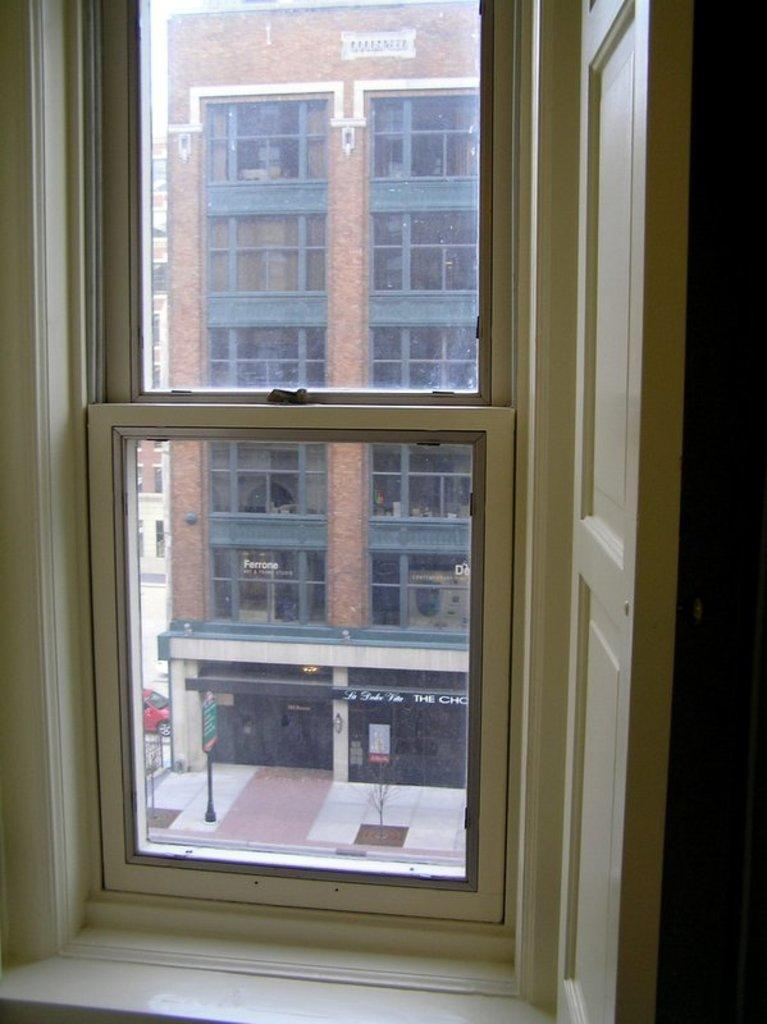What type of structure is visible in the image? There is a glass window in the image. What can be seen through the glass window? The glass window provides a view of buildings. What type of songs can be heard coming from the toad in the image? There is no toad present in the image, and therefore no songs can be heard. 